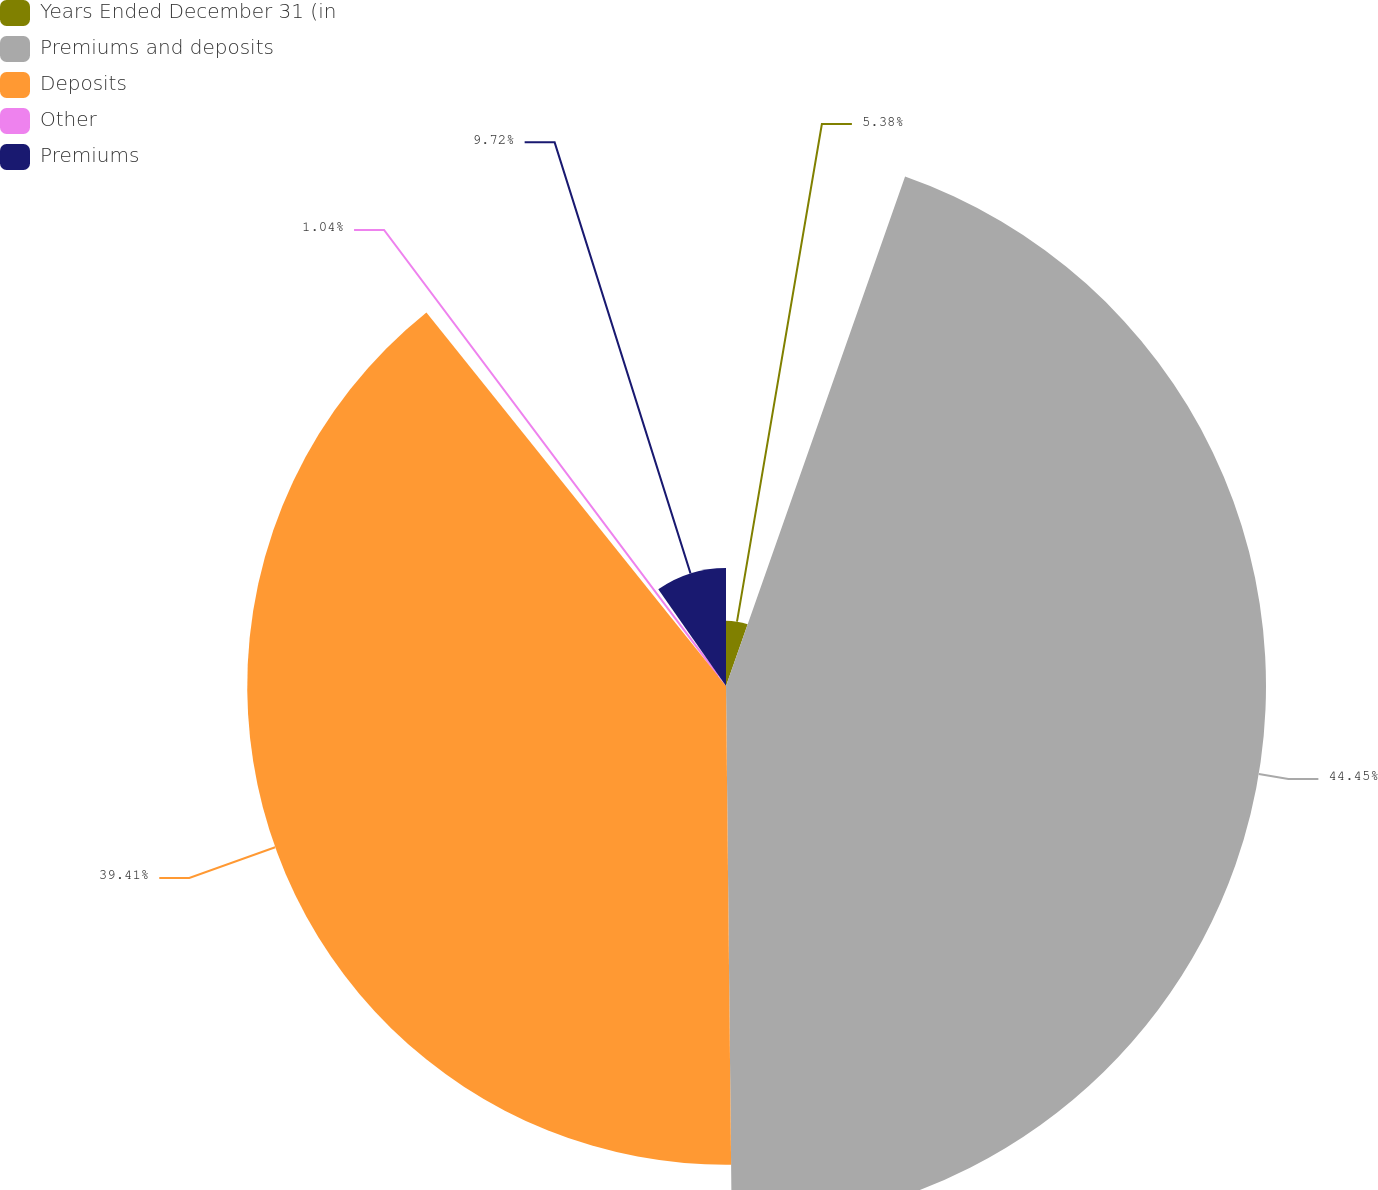Convert chart. <chart><loc_0><loc_0><loc_500><loc_500><pie_chart><fcel>Years Ended December 31 (in<fcel>Premiums and deposits<fcel>Deposits<fcel>Other<fcel>Premiums<nl><fcel>5.38%<fcel>44.45%<fcel>39.41%<fcel>1.04%<fcel>9.72%<nl></chart> 